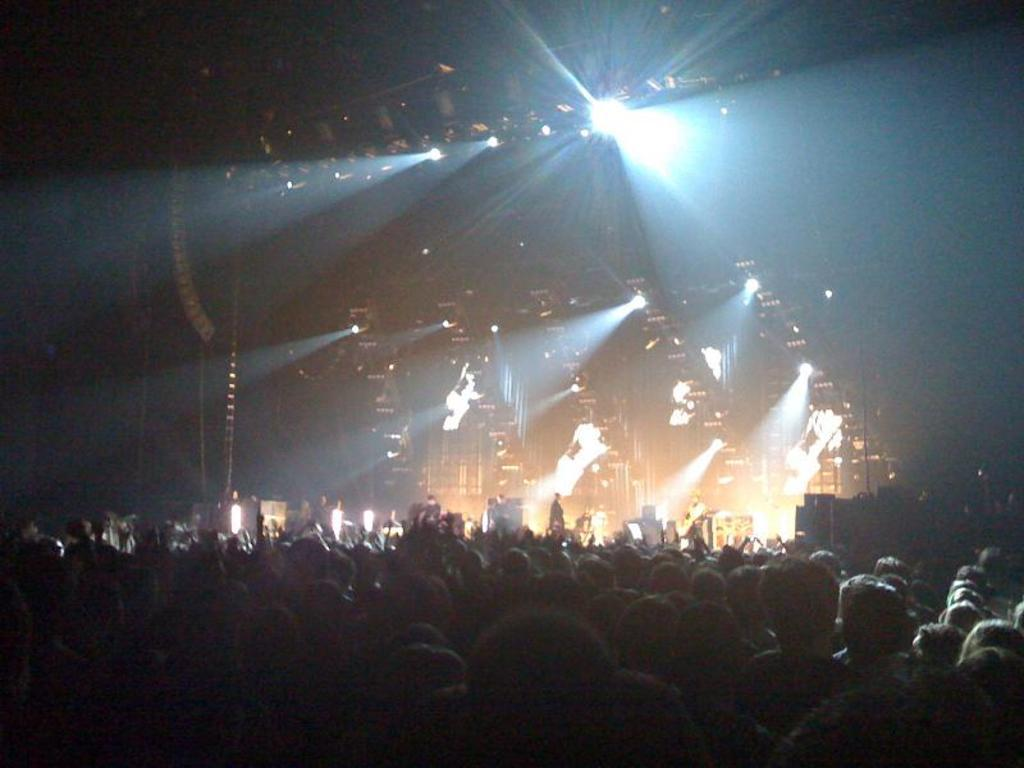Who or what can be seen in the image? There are people in the image. What else is present in the image besides the people? There are lights in the image. What type of corn is being used to inflate the balloon in the image? There is no corn or balloon present in the image. How does the image turn into a different scene? The image does not turn into a different scene; it remains static. 